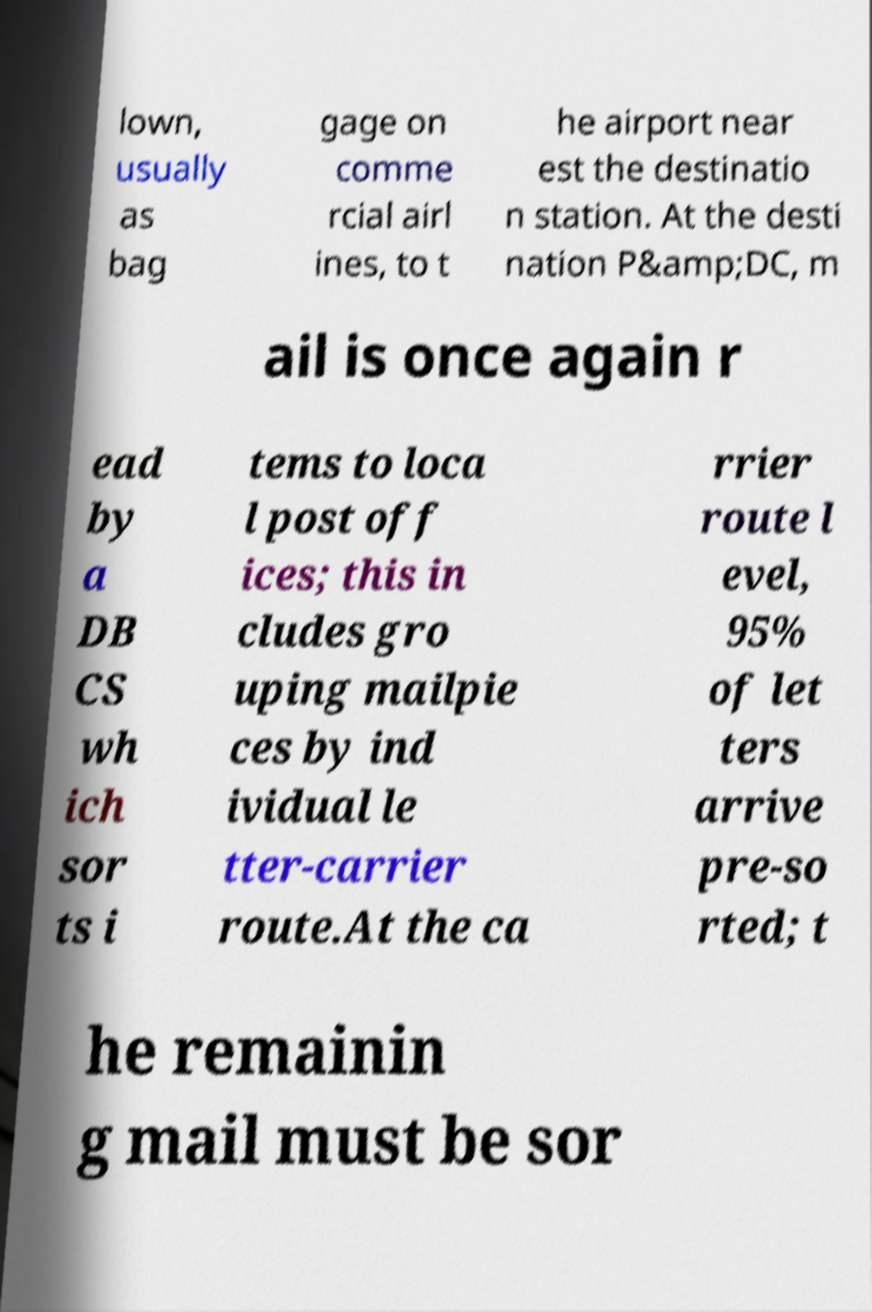For documentation purposes, I need the text within this image transcribed. Could you provide that? lown, usually as bag gage on comme rcial airl ines, to t he airport near est the destinatio n station. At the desti nation P&amp;DC, m ail is once again r ead by a DB CS wh ich sor ts i tems to loca l post off ices; this in cludes gro uping mailpie ces by ind ividual le tter-carrier route.At the ca rrier route l evel, 95% of let ters arrive pre-so rted; t he remainin g mail must be sor 